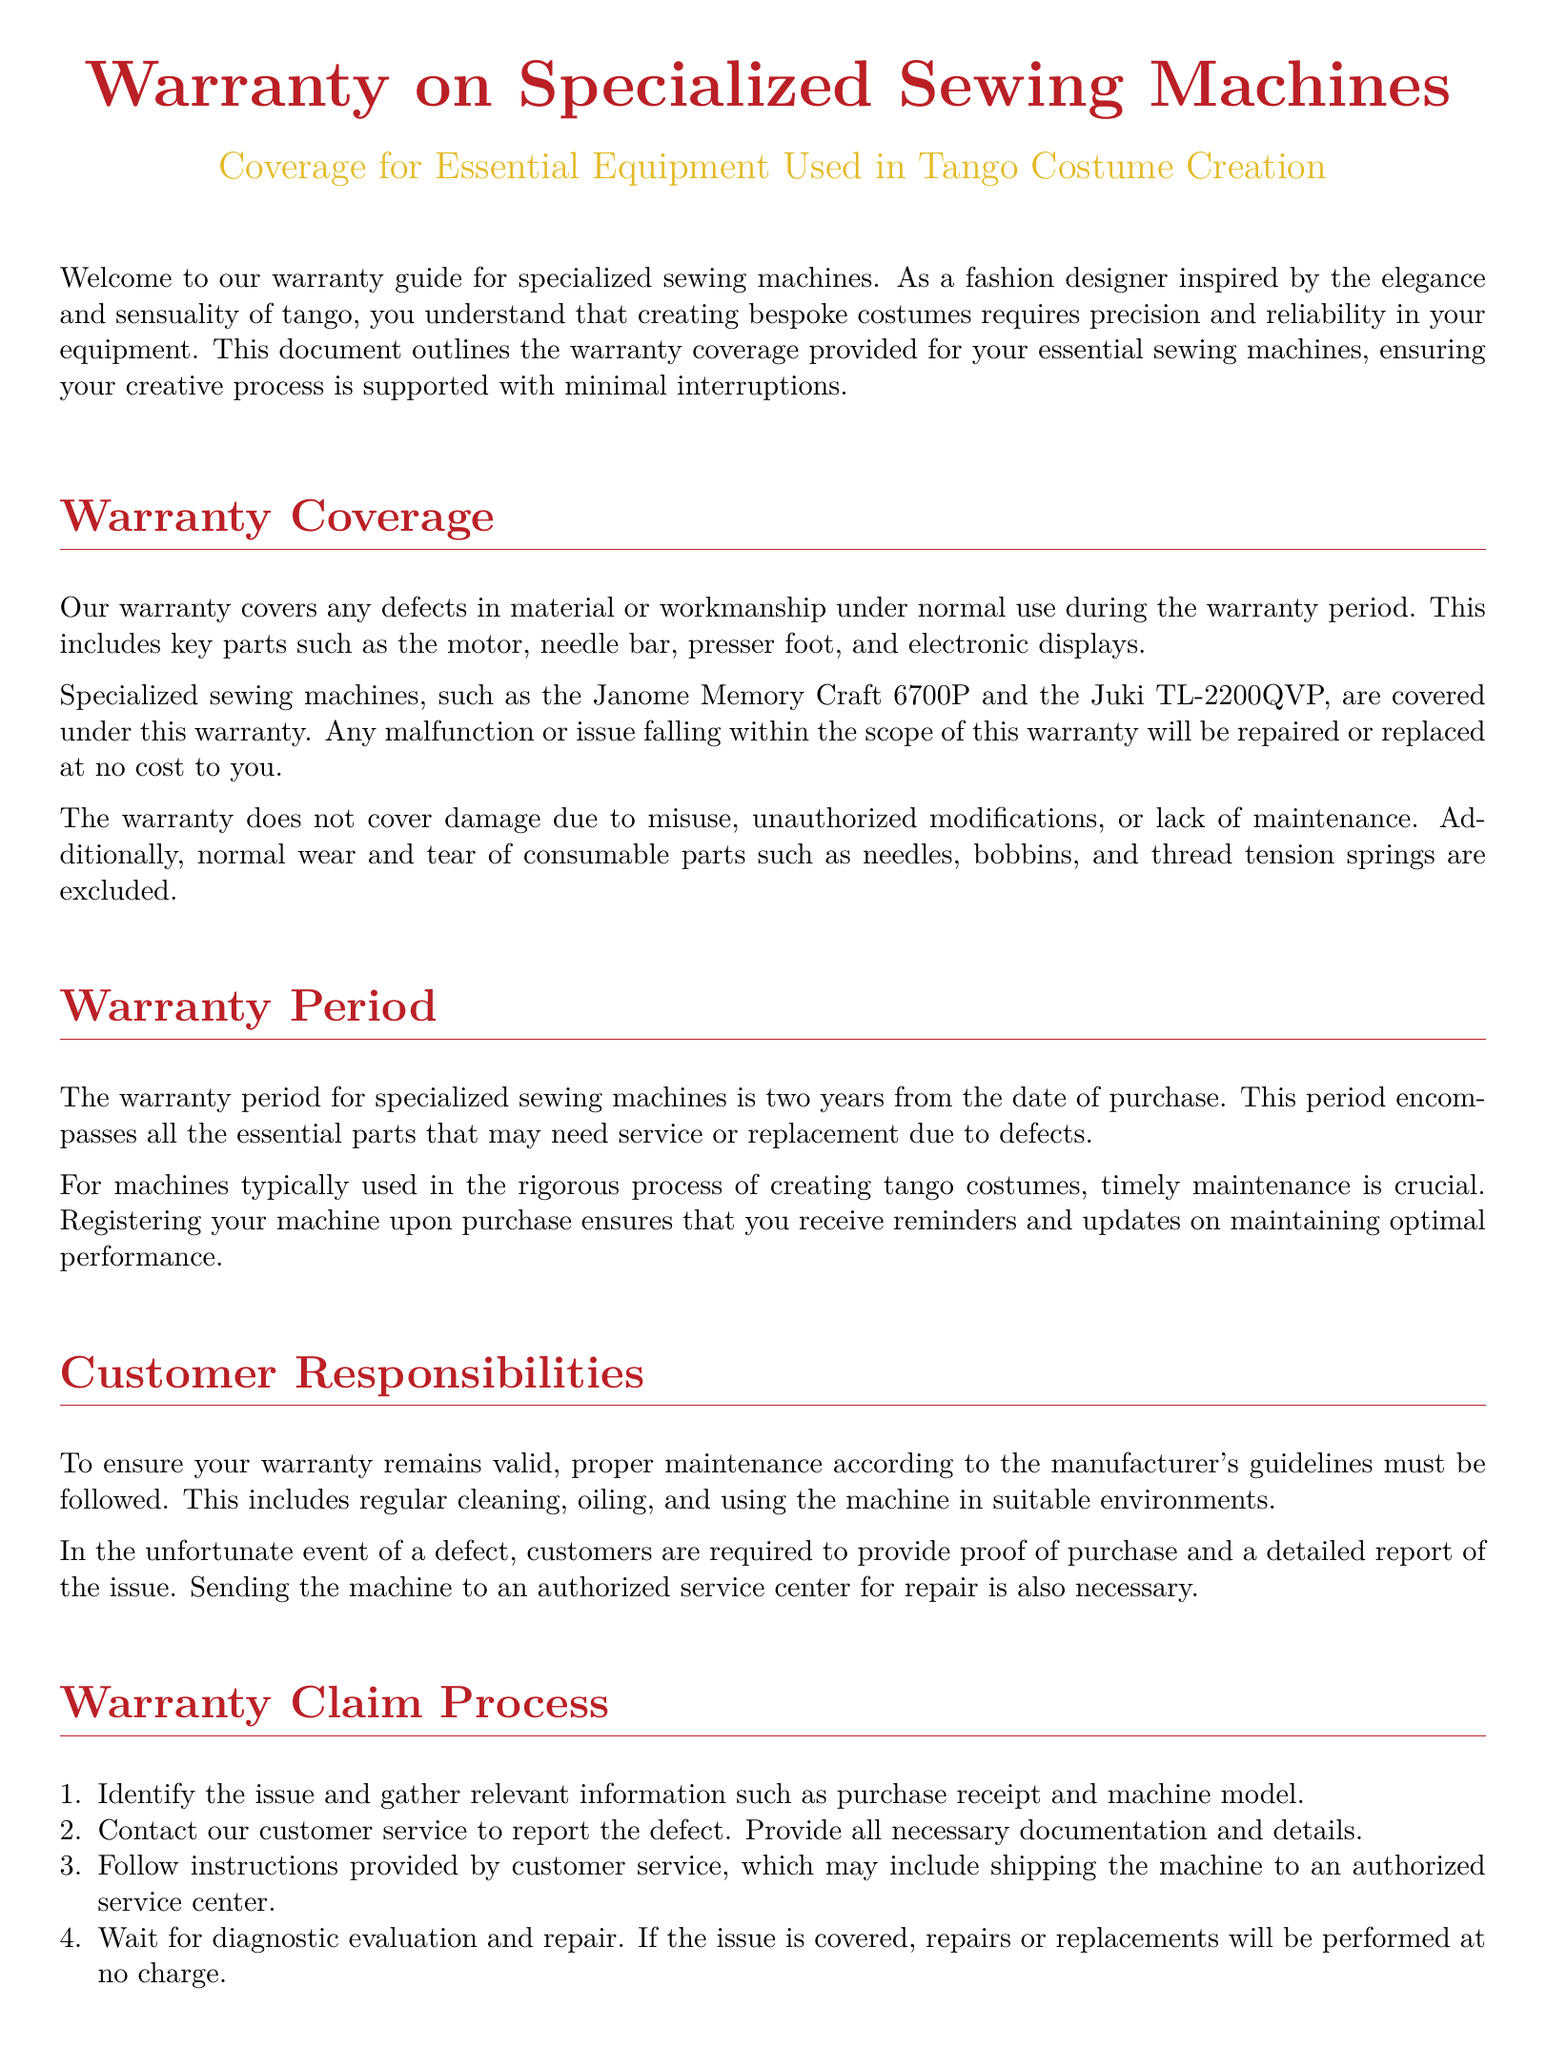What is covered under the warranty? The warranty covers any defects in material or workmanship under normal use during the warranty period, including key parts.
Answer: defects in material or workmanship What is the warranty period for specialized sewing machines? The warranty period is explicitly mentioned as two years from the date of purchase.
Answer: two years Which specialized sewing machines are mentioned in the document? The document specifically lists the Janome Memory Craft 6700P and the Juki TL-2200QVP as examples under warranty.
Answer: Janome Memory Craft 6700P and Juki TL-2200QVP What are customers required to provide in the event of a defect? Customers must provide proof of purchase and a detailed report of the issue.
Answer: proof of purchase and a detailed report What is excluded from the warranty coverage? The warranty does not cover damage due to misuse, unauthorized modifications, or lack of maintenance.
Answer: damage due to misuse What must customers do to ensure their warranty remains valid? Proper maintenance according to the manufacturer's guidelines must be followed.
Answer: proper maintenance How can customers contact customer service? Customers can contact customer service by calling or emailing as listed in the document.
Answer: 1-800-123-4567 or support@tangocouturemachines.com What does the warranty cover regarding normal wear? Normal wear and tear of consumable parts such as needles, bobbins, and thread tension springs are excluded.
Answer: consumable parts What is the first step in the warranty claim process? Identify the issue and gather relevant information such as purchase receipt and machine model.
Answer: Identify the issue 